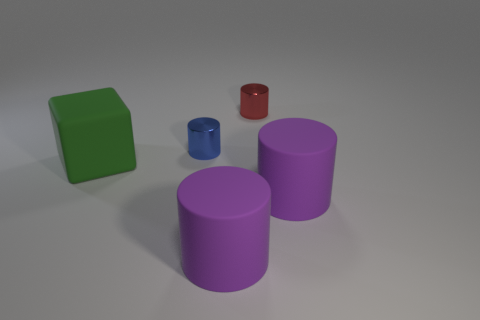How many other things are the same color as the block?
Your answer should be compact. 0. There is a purple cylinder that is behind the purple object that is in front of the rubber object that is right of the small red cylinder; what is it made of?
Offer a very short reply. Rubber. What is the object right of the shiny object on the right side of the blue thing made of?
Your response must be concise. Rubber. Is the number of purple cylinders to the left of the big green thing less than the number of purple things?
Your answer should be very brief. Yes. There is a green rubber thing in front of the small blue shiny object; what shape is it?
Your answer should be very brief. Cube. Do the blue metallic object and the green block that is in front of the blue thing have the same size?
Ensure brevity in your answer.  No. Is there another small thing that has the same material as the green thing?
Offer a terse response. No. What number of cylinders are small red things or small blue metallic things?
Your answer should be very brief. 2. Is there a purple rubber object in front of the small object that is in front of the red metallic cylinder?
Make the answer very short. Yes. Is the number of big blue things less than the number of purple rubber cylinders?
Offer a very short reply. Yes. 